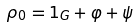Convert formula to latex. <formula><loc_0><loc_0><loc_500><loc_500>\rho _ { 0 } = 1 _ { G } + \varphi + \psi</formula> 